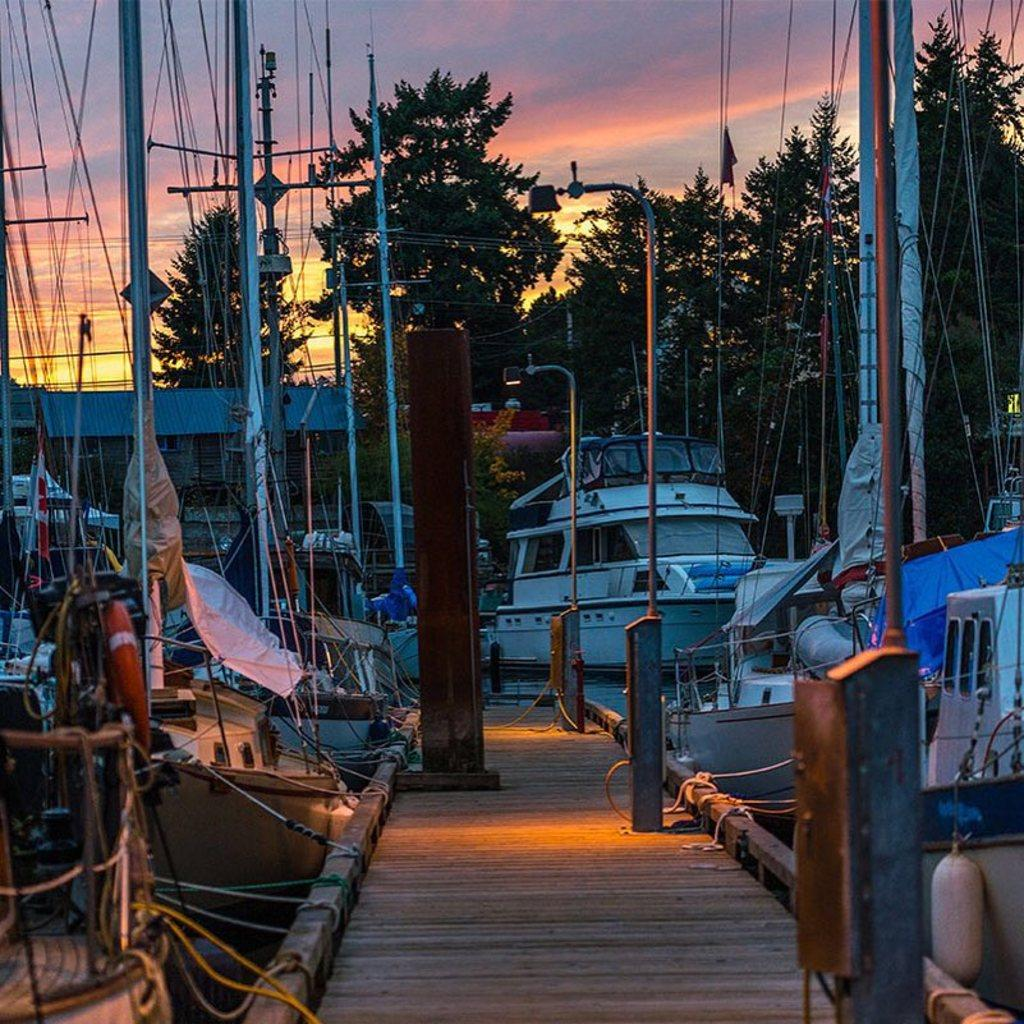What type of vehicles are present in the image? There are boats in the image. What structure can be seen in the background of the image? There is a house in the background of the image. What type of vegetation is visible in the background of the image? There are trees in the background of the image. What is visible at the top of the image? The sky is visible at the top of the image. What type of wool is being used to construct the boats in the image? There is no wool present in the image; the boats are likely made of materials such as wood or metal. 